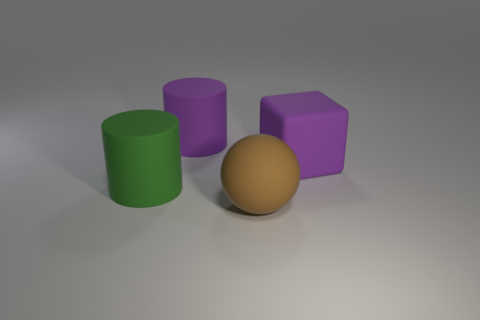There is a large rubber object to the right of the rubber sphere; is it the same color as the rubber ball?
Offer a terse response. No. What number of other objects are the same shape as the big green thing?
Provide a succinct answer. 1. What number of other things are the same material as the purple block?
Your answer should be compact. 3. There is a big sphere in front of the large purple rubber object in front of the purple object left of the ball; what is it made of?
Your answer should be compact. Rubber. Do the large green thing and the ball have the same material?
Provide a succinct answer. Yes. What number of cylinders are either big gray metallic objects or large matte things?
Provide a short and direct response. 2. What color is the large matte thing on the right side of the brown rubber thing?
Your answer should be very brief. Purple. What number of matte objects are either brown things or large yellow cylinders?
Your answer should be compact. 1. There is a cylinder behind the matte thing right of the rubber sphere; what is it made of?
Offer a terse response. Rubber. What material is the object that is the same color as the big matte cube?
Offer a terse response. Rubber. 